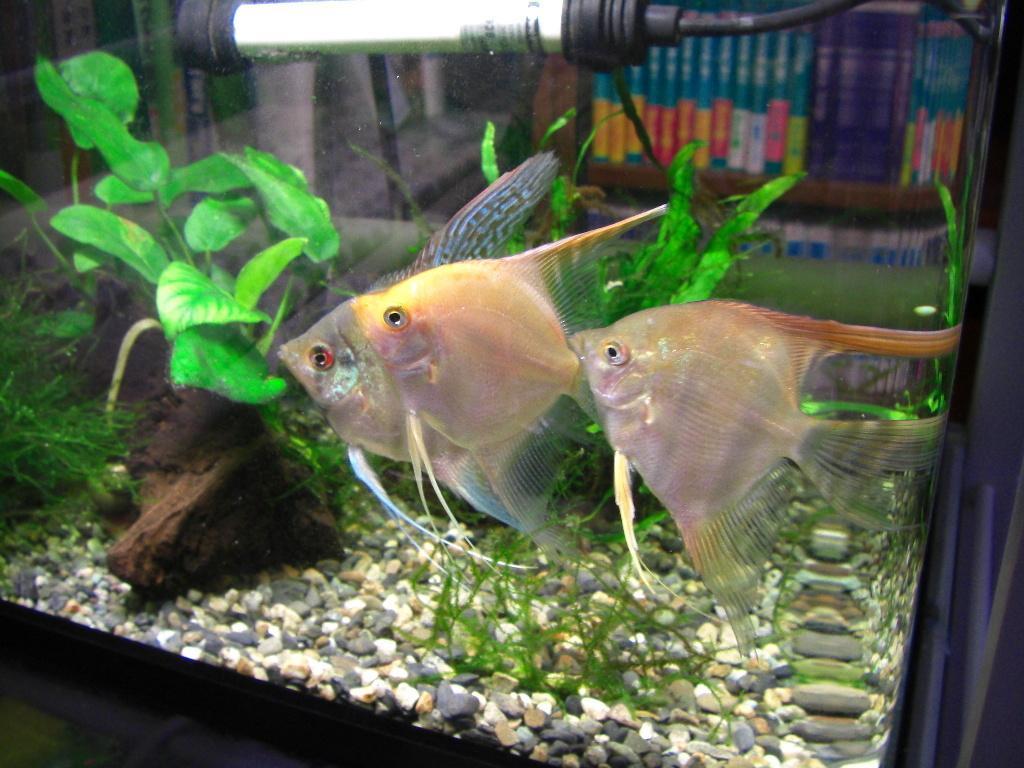In one or two sentences, can you explain what this image depicts? In this picture we observe three fishes in the aquarium which are swimming and in the background we observe trees, stones and lights. 